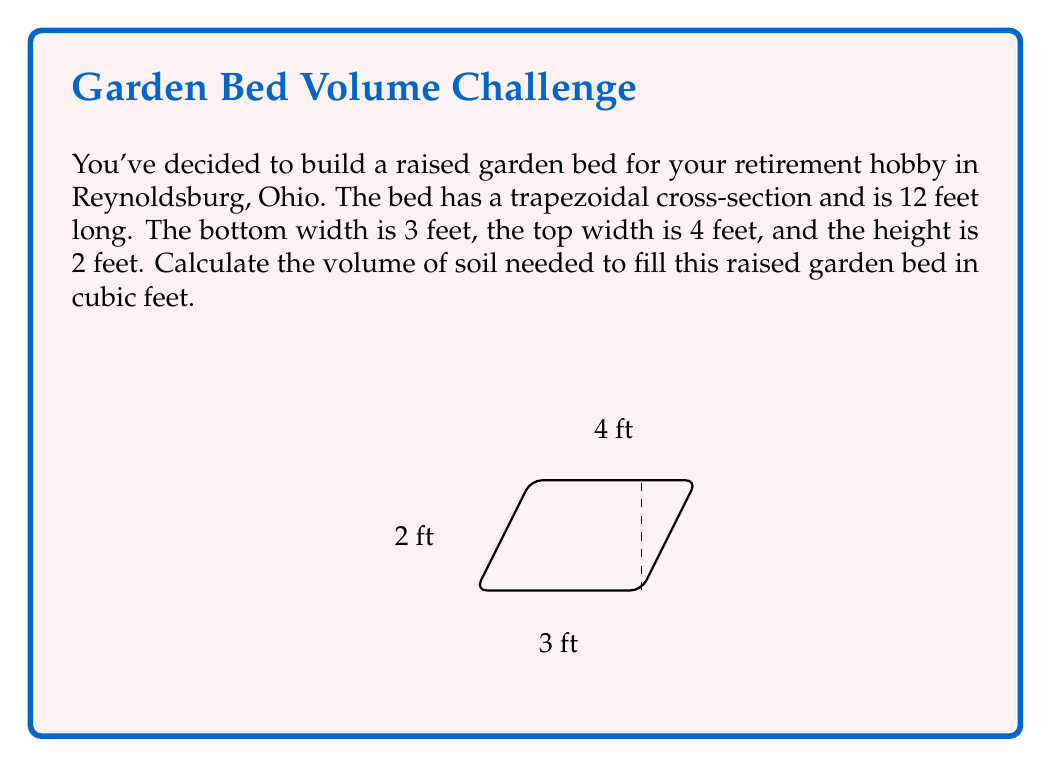Can you answer this question? To find the volume of the raised garden bed, we need to:

1. Calculate the area of the trapezoidal cross-section.
2. Multiply this area by the length of the bed.

Step 1: Calculate the area of the trapezoid
The formula for the area of a trapezoid is:
$$A = \frac{1}{2}(b_1 + b_2)h$$
Where $b_1$ and $b_2$ are the parallel sides and $h$ is the height.

$b_1 = 3$ ft (bottom width)
$b_2 = 4$ ft (top width)
$h = 2$ ft (height)

Substituting these values:
$$A = \frac{1}{2}(3 + 4) \cdot 2 = \frac{1}{2} \cdot 7 \cdot 2 = 7 \text{ sq ft}$$

Step 2: Calculate the volume
The volume is the cross-sectional area multiplied by the length:
$$V = A \cdot l$$
Where $l$ is the length of the bed (12 feet).

$$V = 7 \cdot 12 = 84 \text{ cubic feet}$$

Therefore, the volume of soil needed to fill the raised garden bed is 84 cubic feet.
Answer: 84 cubic feet 